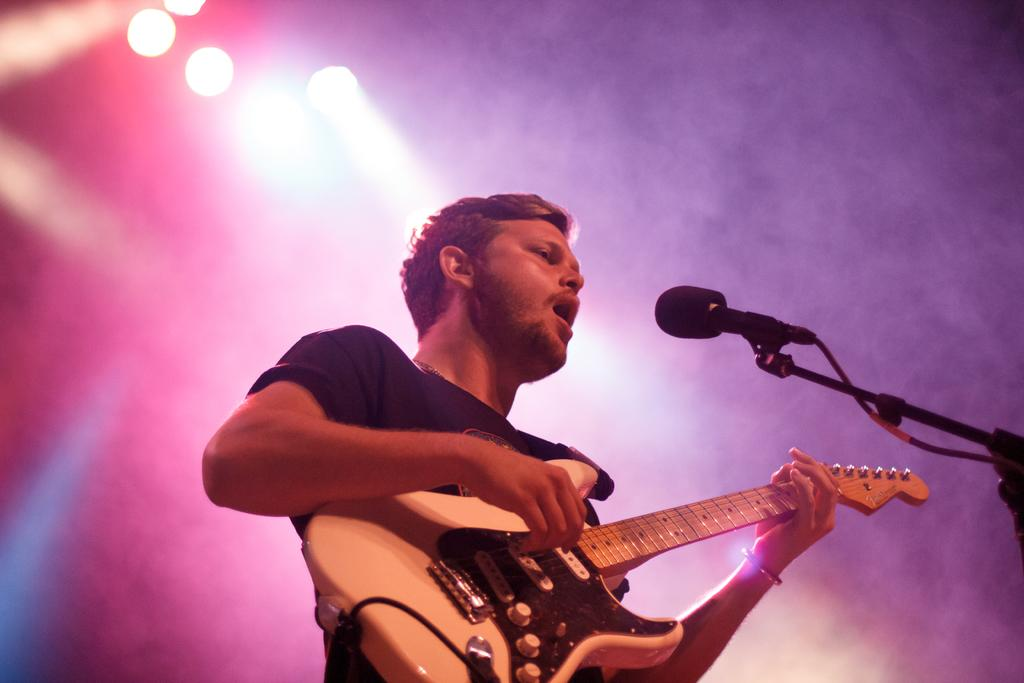What is the man in the image doing? The man is playing a guitar in the image. What object is present that is commonly used for amplifying sound? There is a microphone in the image. What type of hospital is visible in the image? There is no hospital present in the image. What is the man using to serve food in the image? There is no plate or food serving activity present in the image. 